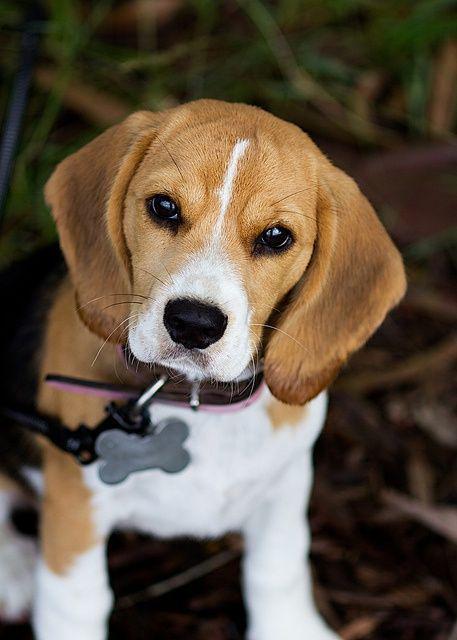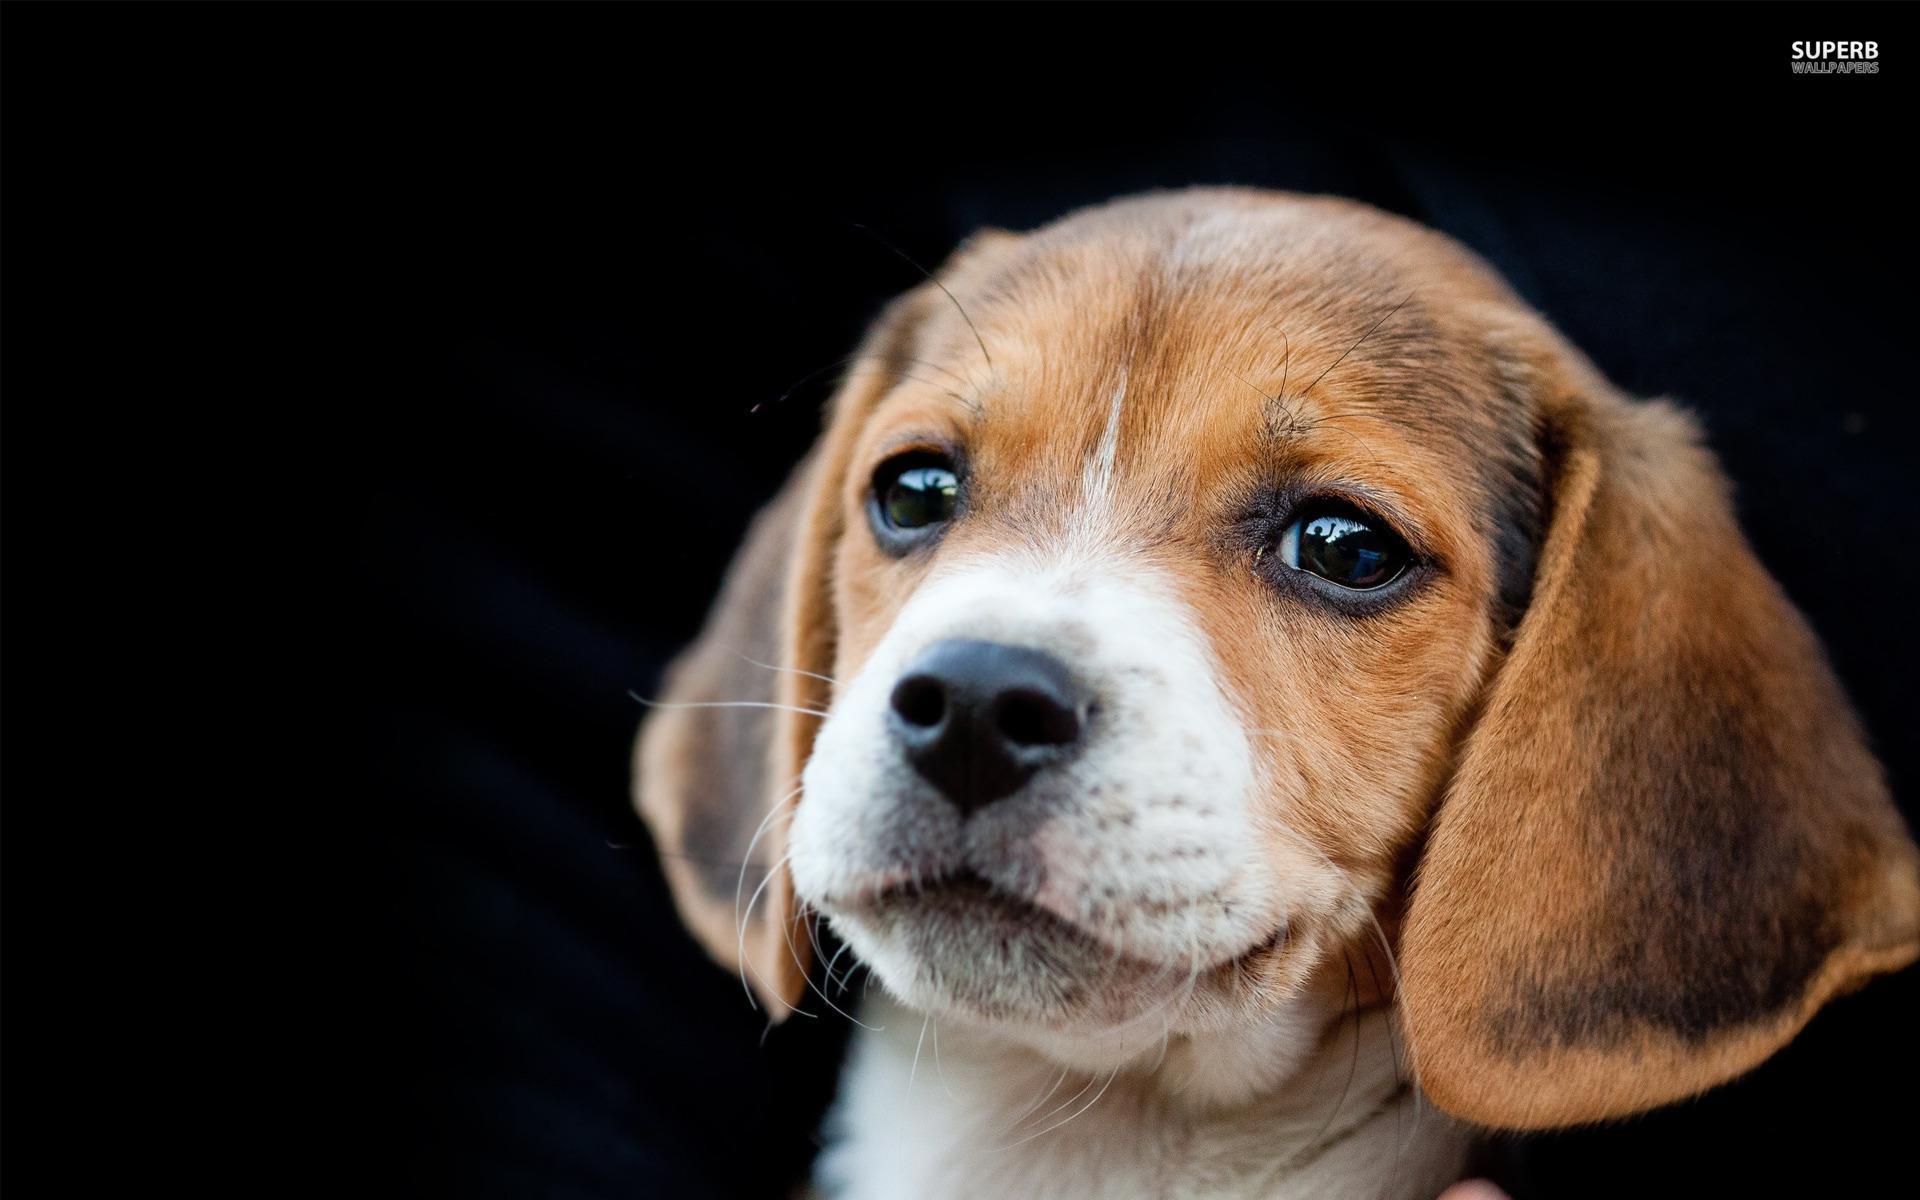The first image is the image on the left, the second image is the image on the right. Assess this claim about the two images: "There are at most two dogs.". Correct or not? Answer yes or no. Yes. 